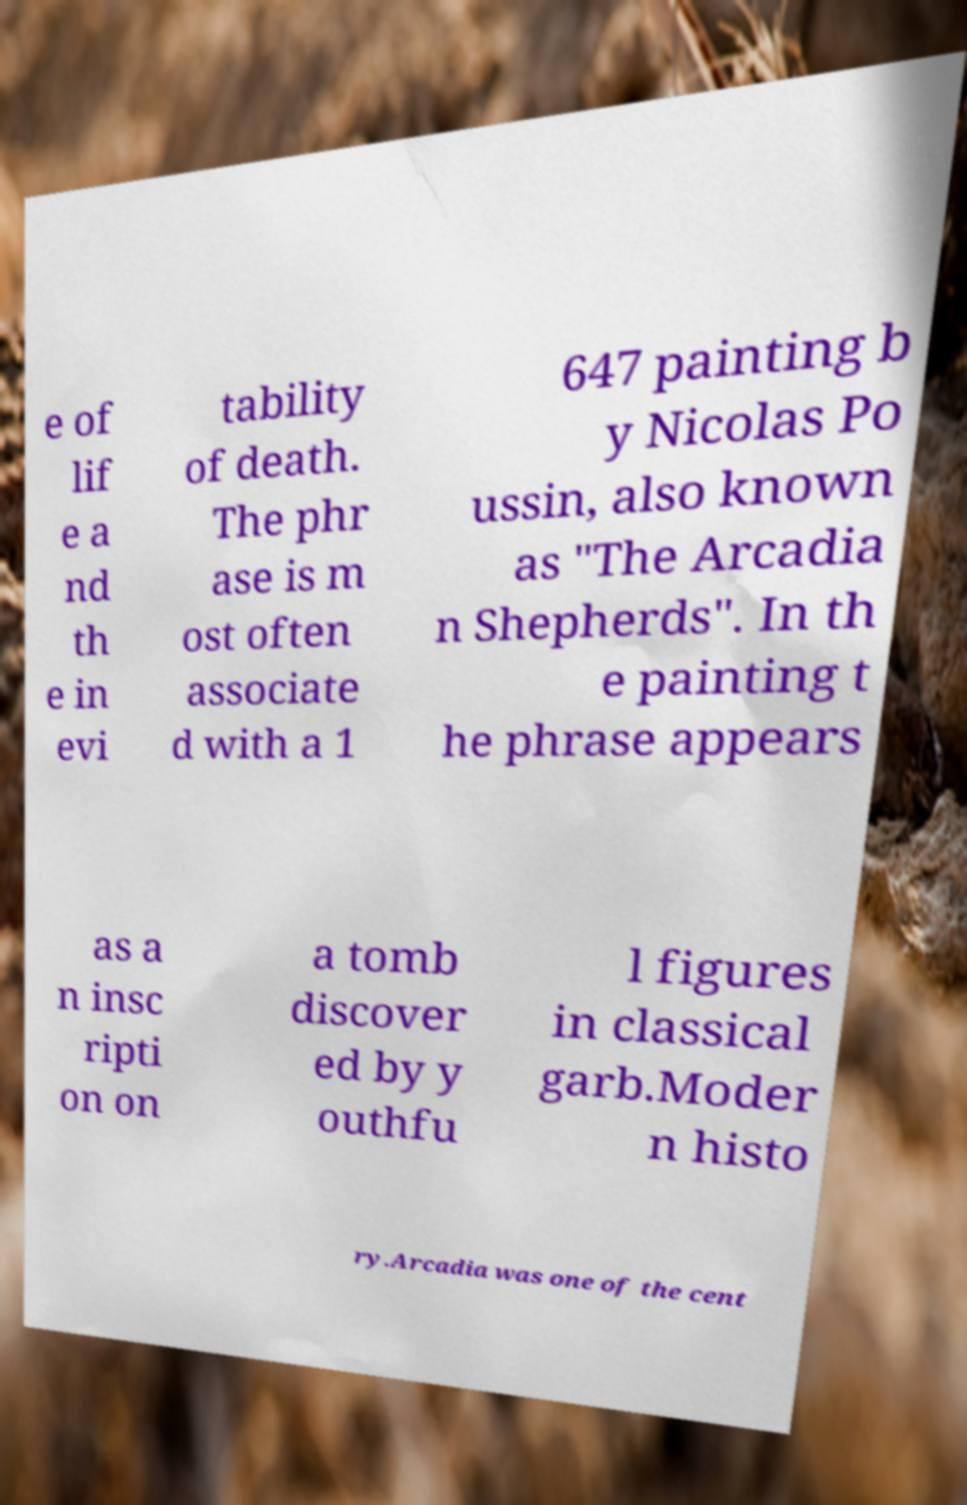Can you accurately transcribe the text from the provided image for me? e of lif e a nd th e in evi tability of death. The phr ase is m ost often associate d with a 1 647 painting b y Nicolas Po ussin, also known as "The Arcadia n Shepherds". In th e painting t he phrase appears as a n insc ripti on on a tomb discover ed by y outhfu l figures in classical garb.Moder n histo ry.Arcadia was one of the cent 